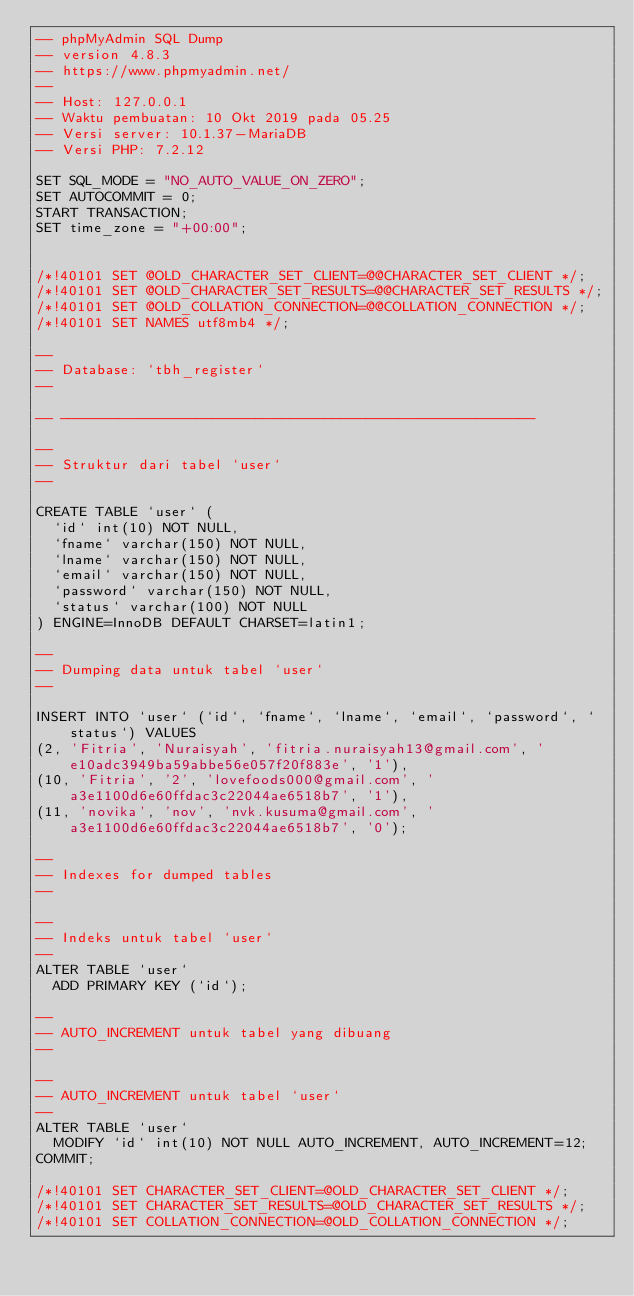Convert code to text. <code><loc_0><loc_0><loc_500><loc_500><_SQL_>-- phpMyAdmin SQL Dump
-- version 4.8.3
-- https://www.phpmyadmin.net/
--
-- Host: 127.0.0.1
-- Waktu pembuatan: 10 Okt 2019 pada 05.25
-- Versi server: 10.1.37-MariaDB
-- Versi PHP: 7.2.12

SET SQL_MODE = "NO_AUTO_VALUE_ON_ZERO";
SET AUTOCOMMIT = 0;
START TRANSACTION;
SET time_zone = "+00:00";


/*!40101 SET @OLD_CHARACTER_SET_CLIENT=@@CHARACTER_SET_CLIENT */;
/*!40101 SET @OLD_CHARACTER_SET_RESULTS=@@CHARACTER_SET_RESULTS */;
/*!40101 SET @OLD_COLLATION_CONNECTION=@@COLLATION_CONNECTION */;
/*!40101 SET NAMES utf8mb4 */;

--
-- Database: `tbh_register`
--

-- --------------------------------------------------------

--
-- Struktur dari tabel `user`
--

CREATE TABLE `user` (
  `id` int(10) NOT NULL,
  `fname` varchar(150) NOT NULL,
  `lname` varchar(150) NOT NULL,
  `email` varchar(150) NOT NULL,
  `password` varchar(150) NOT NULL,
  `status` varchar(100) NOT NULL
) ENGINE=InnoDB DEFAULT CHARSET=latin1;

--
-- Dumping data untuk tabel `user`
--

INSERT INTO `user` (`id`, `fname`, `lname`, `email`, `password`, `status`) VALUES
(2, 'Fitria', 'Nuraisyah', 'fitria.nuraisyah13@gmail.com', 'e10adc3949ba59abbe56e057f20f883e', '1'),
(10, 'Fitria', '2', 'lovefoods000@gmail.com', 'a3e1100d6e60ffdac3c22044ae6518b7', '1'),
(11, 'novika', 'nov', 'nvk.kusuma@gmail.com', 'a3e1100d6e60ffdac3c22044ae6518b7', '0');

--
-- Indexes for dumped tables
--

--
-- Indeks untuk tabel `user`
--
ALTER TABLE `user`
  ADD PRIMARY KEY (`id`);

--
-- AUTO_INCREMENT untuk tabel yang dibuang
--

--
-- AUTO_INCREMENT untuk tabel `user`
--
ALTER TABLE `user`
  MODIFY `id` int(10) NOT NULL AUTO_INCREMENT, AUTO_INCREMENT=12;
COMMIT;

/*!40101 SET CHARACTER_SET_CLIENT=@OLD_CHARACTER_SET_CLIENT */;
/*!40101 SET CHARACTER_SET_RESULTS=@OLD_CHARACTER_SET_RESULTS */;
/*!40101 SET COLLATION_CONNECTION=@OLD_COLLATION_CONNECTION */;
</code> 